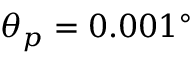Convert formula to latex. <formula><loc_0><loc_0><loc_500><loc_500>\theta _ { p } = 0 . 0 0 1 ^ { \circ }</formula> 